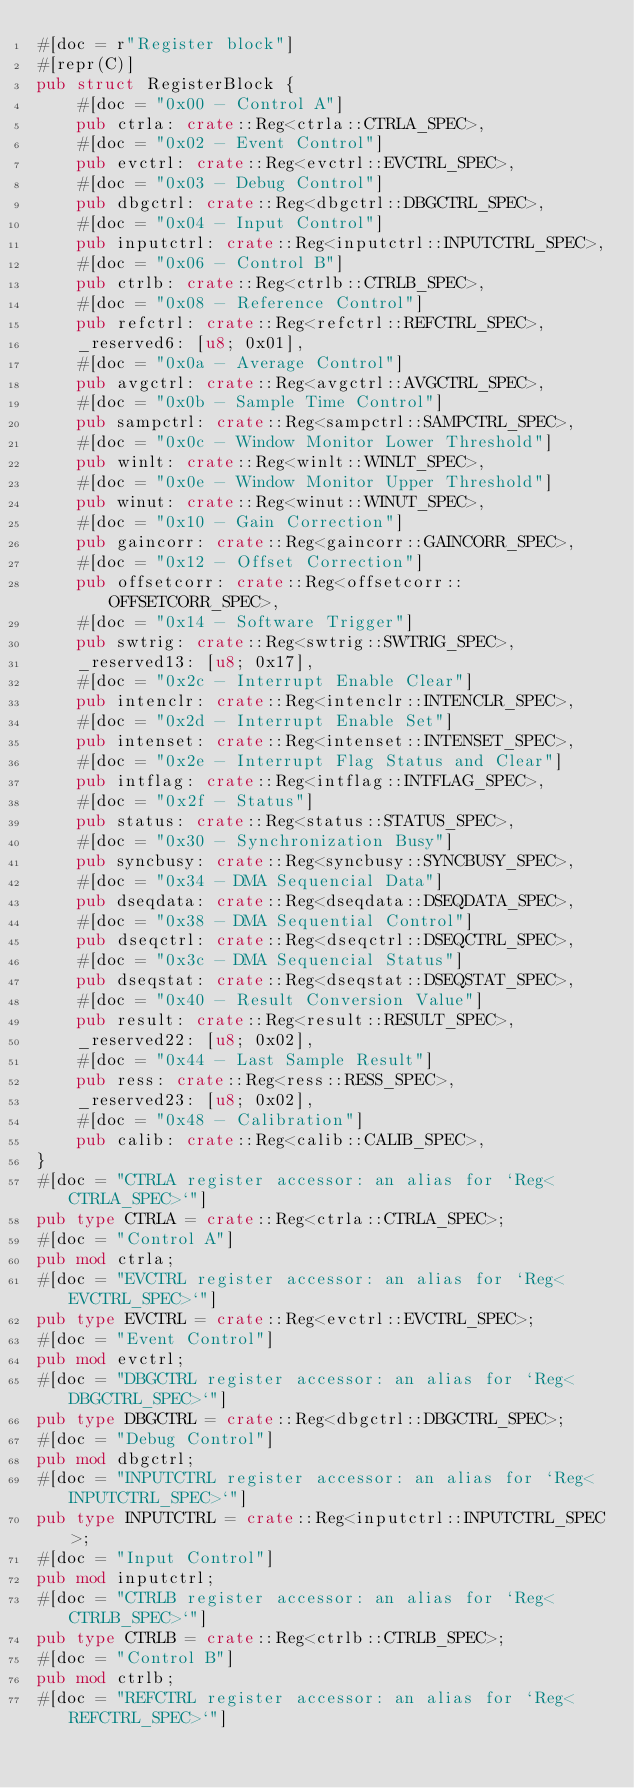Convert code to text. <code><loc_0><loc_0><loc_500><loc_500><_Rust_>#[doc = r"Register block"]
#[repr(C)]
pub struct RegisterBlock {
    #[doc = "0x00 - Control A"]
    pub ctrla: crate::Reg<ctrla::CTRLA_SPEC>,
    #[doc = "0x02 - Event Control"]
    pub evctrl: crate::Reg<evctrl::EVCTRL_SPEC>,
    #[doc = "0x03 - Debug Control"]
    pub dbgctrl: crate::Reg<dbgctrl::DBGCTRL_SPEC>,
    #[doc = "0x04 - Input Control"]
    pub inputctrl: crate::Reg<inputctrl::INPUTCTRL_SPEC>,
    #[doc = "0x06 - Control B"]
    pub ctrlb: crate::Reg<ctrlb::CTRLB_SPEC>,
    #[doc = "0x08 - Reference Control"]
    pub refctrl: crate::Reg<refctrl::REFCTRL_SPEC>,
    _reserved6: [u8; 0x01],
    #[doc = "0x0a - Average Control"]
    pub avgctrl: crate::Reg<avgctrl::AVGCTRL_SPEC>,
    #[doc = "0x0b - Sample Time Control"]
    pub sampctrl: crate::Reg<sampctrl::SAMPCTRL_SPEC>,
    #[doc = "0x0c - Window Monitor Lower Threshold"]
    pub winlt: crate::Reg<winlt::WINLT_SPEC>,
    #[doc = "0x0e - Window Monitor Upper Threshold"]
    pub winut: crate::Reg<winut::WINUT_SPEC>,
    #[doc = "0x10 - Gain Correction"]
    pub gaincorr: crate::Reg<gaincorr::GAINCORR_SPEC>,
    #[doc = "0x12 - Offset Correction"]
    pub offsetcorr: crate::Reg<offsetcorr::OFFSETCORR_SPEC>,
    #[doc = "0x14 - Software Trigger"]
    pub swtrig: crate::Reg<swtrig::SWTRIG_SPEC>,
    _reserved13: [u8; 0x17],
    #[doc = "0x2c - Interrupt Enable Clear"]
    pub intenclr: crate::Reg<intenclr::INTENCLR_SPEC>,
    #[doc = "0x2d - Interrupt Enable Set"]
    pub intenset: crate::Reg<intenset::INTENSET_SPEC>,
    #[doc = "0x2e - Interrupt Flag Status and Clear"]
    pub intflag: crate::Reg<intflag::INTFLAG_SPEC>,
    #[doc = "0x2f - Status"]
    pub status: crate::Reg<status::STATUS_SPEC>,
    #[doc = "0x30 - Synchronization Busy"]
    pub syncbusy: crate::Reg<syncbusy::SYNCBUSY_SPEC>,
    #[doc = "0x34 - DMA Sequencial Data"]
    pub dseqdata: crate::Reg<dseqdata::DSEQDATA_SPEC>,
    #[doc = "0x38 - DMA Sequential Control"]
    pub dseqctrl: crate::Reg<dseqctrl::DSEQCTRL_SPEC>,
    #[doc = "0x3c - DMA Sequencial Status"]
    pub dseqstat: crate::Reg<dseqstat::DSEQSTAT_SPEC>,
    #[doc = "0x40 - Result Conversion Value"]
    pub result: crate::Reg<result::RESULT_SPEC>,
    _reserved22: [u8; 0x02],
    #[doc = "0x44 - Last Sample Result"]
    pub ress: crate::Reg<ress::RESS_SPEC>,
    _reserved23: [u8; 0x02],
    #[doc = "0x48 - Calibration"]
    pub calib: crate::Reg<calib::CALIB_SPEC>,
}
#[doc = "CTRLA register accessor: an alias for `Reg<CTRLA_SPEC>`"]
pub type CTRLA = crate::Reg<ctrla::CTRLA_SPEC>;
#[doc = "Control A"]
pub mod ctrla;
#[doc = "EVCTRL register accessor: an alias for `Reg<EVCTRL_SPEC>`"]
pub type EVCTRL = crate::Reg<evctrl::EVCTRL_SPEC>;
#[doc = "Event Control"]
pub mod evctrl;
#[doc = "DBGCTRL register accessor: an alias for `Reg<DBGCTRL_SPEC>`"]
pub type DBGCTRL = crate::Reg<dbgctrl::DBGCTRL_SPEC>;
#[doc = "Debug Control"]
pub mod dbgctrl;
#[doc = "INPUTCTRL register accessor: an alias for `Reg<INPUTCTRL_SPEC>`"]
pub type INPUTCTRL = crate::Reg<inputctrl::INPUTCTRL_SPEC>;
#[doc = "Input Control"]
pub mod inputctrl;
#[doc = "CTRLB register accessor: an alias for `Reg<CTRLB_SPEC>`"]
pub type CTRLB = crate::Reg<ctrlb::CTRLB_SPEC>;
#[doc = "Control B"]
pub mod ctrlb;
#[doc = "REFCTRL register accessor: an alias for `Reg<REFCTRL_SPEC>`"]</code> 